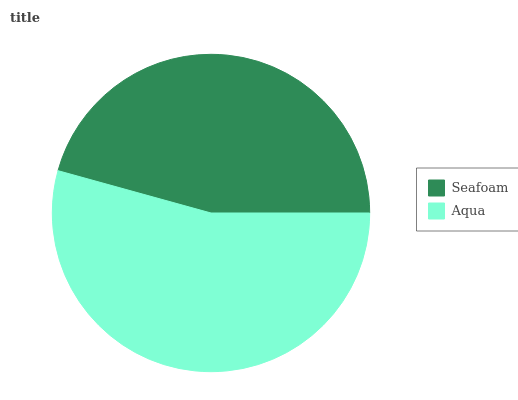Is Seafoam the minimum?
Answer yes or no. Yes. Is Aqua the maximum?
Answer yes or no. Yes. Is Aqua the minimum?
Answer yes or no. No. Is Aqua greater than Seafoam?
Answer yes or no. Yes. Is Seafoam less than Aqua?
Answer yes or no. Yes. Is Seafoam greater than Aqua?
Answer yes or no. No. Is Aqua less than Seafoam?
Answer yes or no. No. Is Aqua the high median?
Answer yes or no. Yes. Is Seafoam the low median?
Answer yes or no. Yes. Is Seafoam the high median?
Answer yes or no. No. Is Aqua the low median?
Answer yes or no. No. 